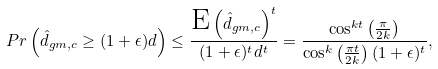<formula> <loc_0><loc_0><loc_500><loc_500>P r \left ( \hat { d } _ { g m , c } \geq ( 1 + \epsilon ) d \right ) \leq \frac { \text {E} \left ( \hat { d } _ { g m , c } \right ) ^ { t } } { ( 1 + \epsilon ) ^ { t } d ^ { t } } = \frac { \cos ^ { k t } \left ( \frac { \pi } { 2 k } \right ) } { \cos ^ { k } \left ( \frac { \pi t } { 2 k } \right ) ( 1 + \epsilon ) ^ { t } } ,</formula> 